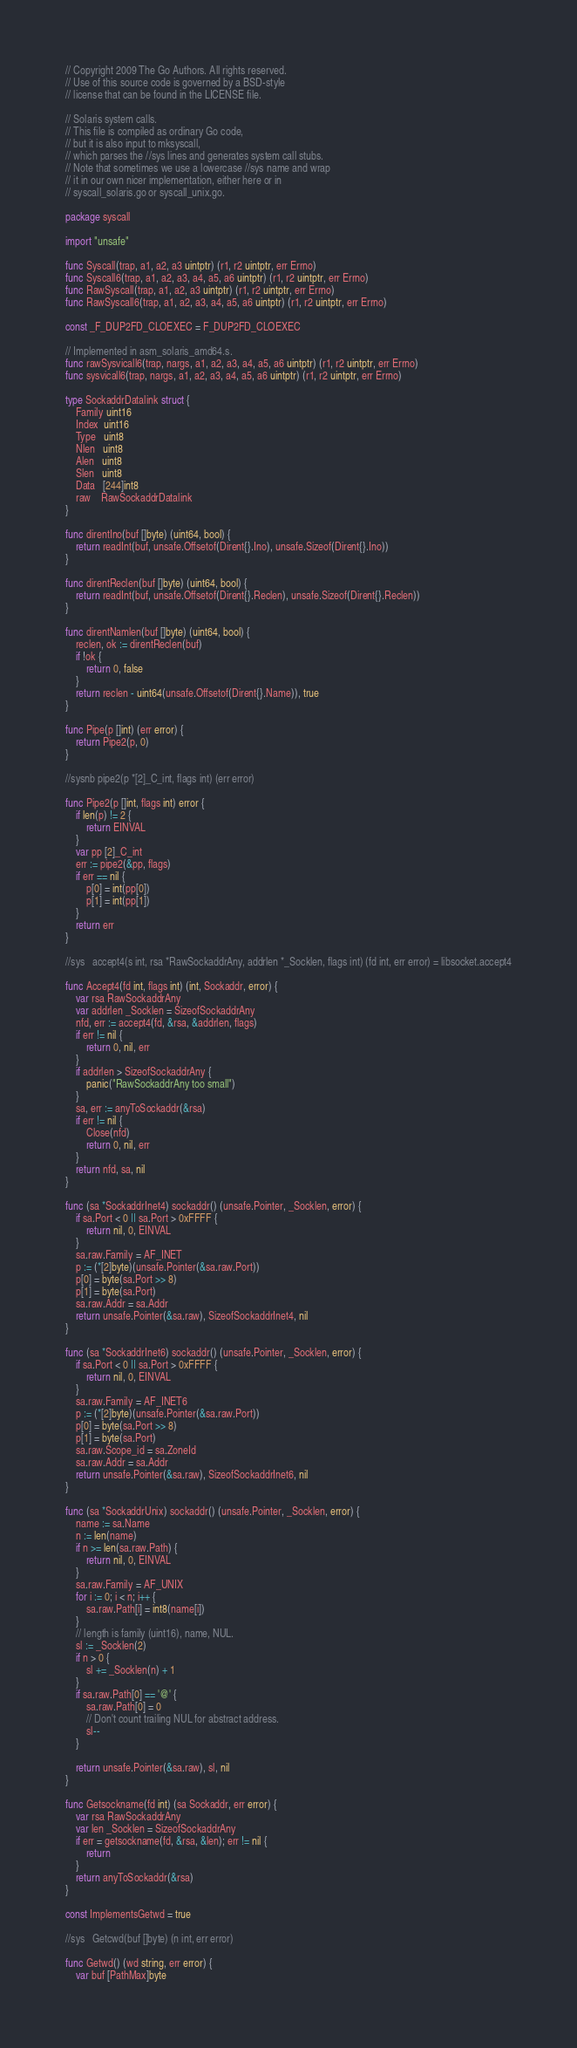<code> <loc_0><loc_0><loc_500><loc_500><_Go_>// Copyright 2009 The Go Authors. All rights reserved.
// Use of this source code is governed by a BSD-style
// license that can be found in the LICENSE file.

// Solaris system calls.
// This file is compiled as ordinary Go code,
// but it is also input to mksyscall,
// which parses the //sys lines and generates system call stubs.
// Note that sometimes we use a lowercase //sys name and wrap
// it in our own nicer implementation, either here or in
// syscall_solaris.go or syscall_unix.go.

package syscall

import "unsafe"

func Syscall(trap, a1, a2, a3 uintptr) (r1, r2 uintptr, err Errno)
func Syscall6(trap, a1, a2, a3, a4, a5, a6 uintptr) (r1, r2 uintptr, err Errno)
func RawSyscall(trap, a1, a2, a3 uintptr) (r1, r2 uintptr, err Errno)
func RawSyscall6(trap, a1, a2, a3, a4, a5, a6 uintptr) (r1, r2 uintptr, err Errno)

const _F_DUP2FD_CLOEXEC = F_DUP2FD_CLOEXEC

// Implemented in asm_solaris_amd64.s.
func rawSysvicall6(trap, nargs, a1, a2, a3, a4, a5, a6 uintptr) (r1, r2 uintptr, err Errno)
func sysvicall6(trap, nargs, a1, a2, a3, a4, a5, a6 uintptr) (r1, r2 uintptr, err Errno)

type SockaddrDatalink struct {
	Family uint16
	Index  uint16
	Type   uint8
	Nlen   uint8
	Alen   uint8
	Slen   uint8
	Data   [244]int8
	raw    RawSockaddrDatalink
}

func direntIno(buf []byte) (uint64, bool) {
	return readInt(buf, unsafe.Offsetof(Dirent{}.Ino), unsafe.Sizeof(Dirent{}.Ino))
}

func direntReclen(buf []byte) (uint64, bool) {
	return readInt(buf, unsafe.Offsetof(Dirent{}.Reclen), unsafe.Sizeof(Dirent{}.Reclen))
}

func direntNamlen(buf []byte) (uint64, bool) {
	reclen, ok := direntReclen(buf)
	if !ok {
		return 0, false
	}
	return reclen - uint64(unsafe.Offsetof(Dirent{}.Name)), true
}

func Pipe(p []int) (err error) {
	return Pipe2(p, 0)
}

//sysnb	pipe2(p *[2]_C_int, flags int) (err error)

func Pipe2(p []int, flags int) error {
	if len(p) != 2 {
		return EINVAL
	}
	var pp [2]_C_int
	err := pipe2(&pp, flags)
	if err == nil {
		p[0] = int(pp[0])
		p[1] = int(pp[1])
	}
	return err
}

//sys   accept4(s int, rsa *RawSockaddrAny, addrlen *_Socklen, flags int) (fd int, err error) = libsocket.accept4

func Accept4(fd int, flags int) (int, Sockaddr, error) {
	var rsa RawSockaddrAny
	var addrlen _Socklen = SizeofSockaddrAny
	nfd, err := accept4(fd, &rsa, &addrlen, flags)
	if err != nil {
		return 0, nil, err
	}
	if addrlen > SizeofSockaddrAny {
		panic("RawSockaddrAny too small")
	}
	sa, err := anyToSockaddr(&rsa)
	if err != nil {
		Close(nfd)
		return 0, nil, err
	}
	return nfd, sa, nil
}

func (sa *SockaddrInet4) sockaddr() (unsafe.Pointer, _Socklen, error) {
	if sa.Port < 0 || sa.Port > 0xFFFF {
		return nil, 0, EINVAL
	}
	sa.raw.Family = AF_INET
	p := (*[2]byte)(unsafe.Pointer(&sa.raw.Port))
	p[0] = byte(sa.Port >> 8)
	p[1] = byte(sa.Port)
	sa.raw.Addr = sa.Addr
	return unsafe.Pointer(&sa.raw), SizeofSockaddrInet4, nil
}

func (sa *SockaddrInet6) sockaddr() (unsafe.Pointer, _Socklen, error) {
	if sa.Port < 0 || sa.Port > 0xFFFF {
		return nil, 0, EINVAL
	}
	sa.raw.Family = AF_INET6
	p := (*[2]byte)(unsafe.Pointer(&sa.raw.Port))
	p[0] = byte(sa.Port >> 8)
	p[1] = byte(sa.Port)
	sa.raw.Scope_id = sa.ZoneId
	sa.raw.Addr = sa.Addr
	return unsafe.Pointer(&sa.raw), SizeofSockaddrInet6, nil
}

func (sa *SockaddrUnix) sockaddr() (unsafe.Pointer, _Socklen, error) {
	name := sa.Name
	n := len(name)
	if n >= len(sa.raw.Path) {
		return nil, 0, EINVAL
	}
	sa.raw.Family = AF_UNIX
	for i := 0; i < n; i++ {
		sa.raw.Path[i] = int8(name[i])
	}
	// length is family (uint16), name, NUL.
	sl := _Socklen(2)
	if n > 0 {
		sl += _Socklen(n) + 1
	}
	if sa.raw.Path[0] == '@' {
		sa.raw.Path[0] = 0
		// Don't count trailing NUL for abstract address.
		sl--
	}

	return unsafe.Pointer(&sa.raw), sl, nil
}

func Getsockname(fd int) (sa Sockaddr, err error) {
	var rsa RawSockaddrAny
	var len _Socklen = SizeofSockaddrAny
	if err = getsockname(fd, &rsa, &len); err != nil {
		return
	}
	return anyToSockaddr(&rsa)
}

const ImplementsGetwd = true

//sys	Getcwd(buf []byte) (n int, err error)

func Getwd() (wd string, err error) {
	var buf [PathMax]byte</code> 